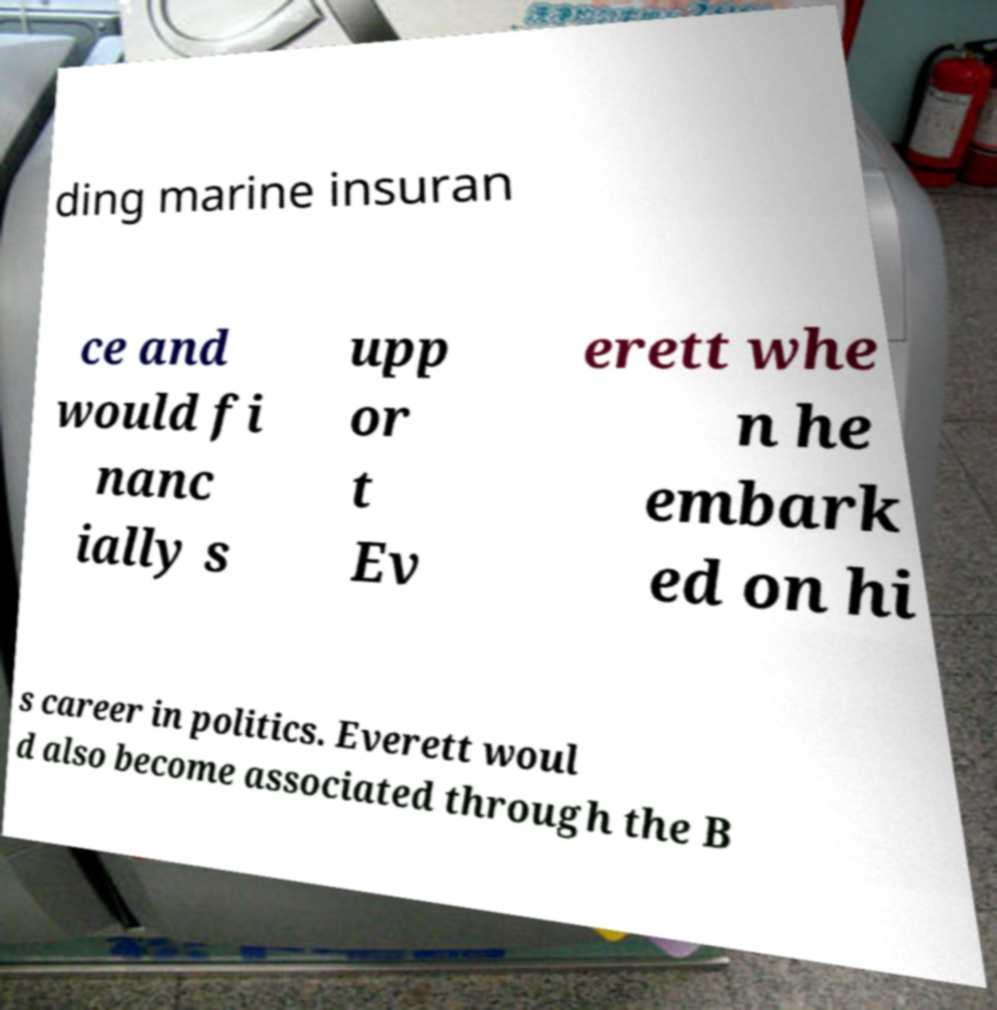Please read and relay the text visible in this image. What does it say? ding marine insuran ce and would fi nanc ially s upp or t Ev erett whe n he embark ed on hi s career in politics. Everett woul d also become associated through the B 